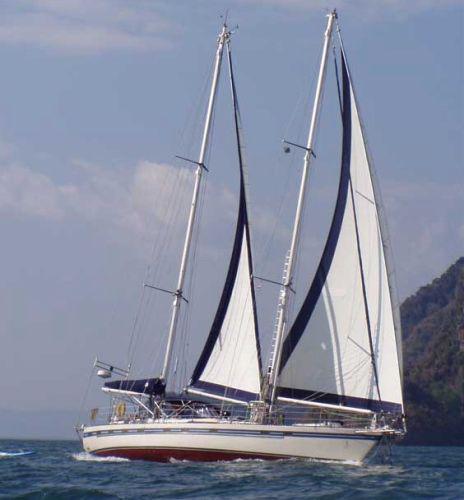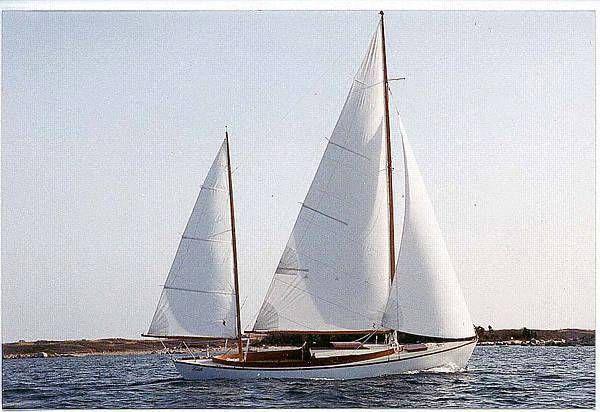The first image is the image on the left, the second image is the image on the right. Given the left and right images, does the statement "There is visible land in the background of at least one image." hold true? Answer yes or no. Yes. 